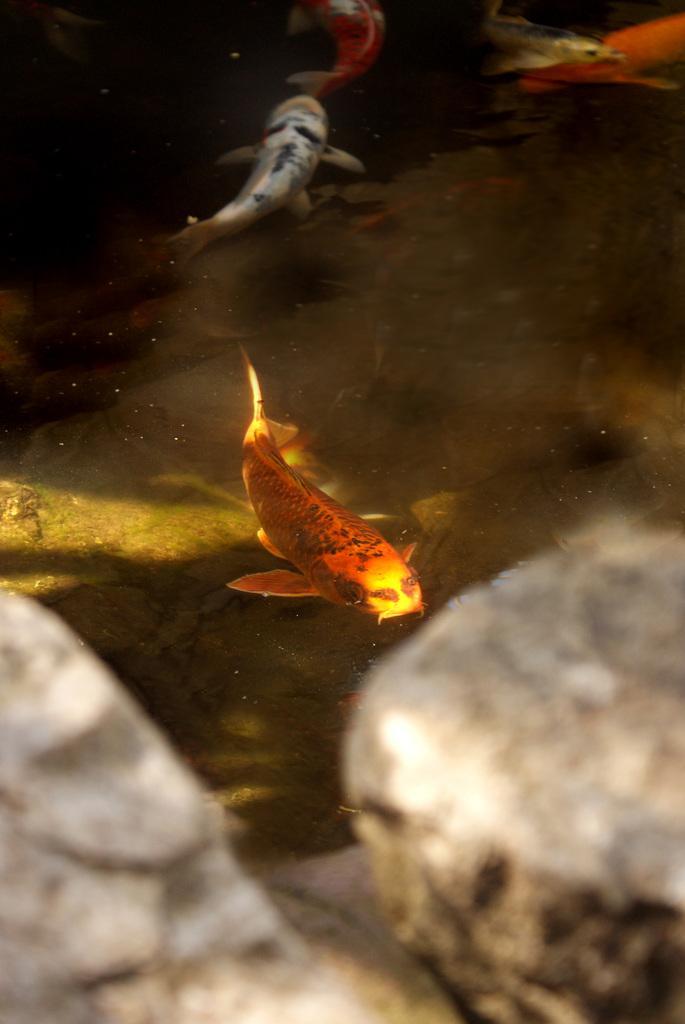Please provide a concise description of this image. In this picture we can see some fishes, stones are in the water. 